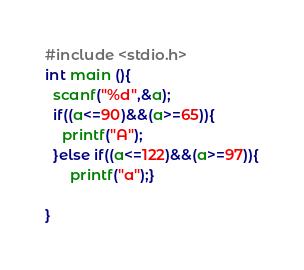<code> <loc_0><loc_0><loc_500><loc_500><_C_>#include <stdio.h>
int main (){
  scanf("%d",&a);
  if((a<=90)&&(a>=65)){
    printf("A");
  }else if((a<=122)&&(a>=97)){
      printf("a");}
  
}</code> 